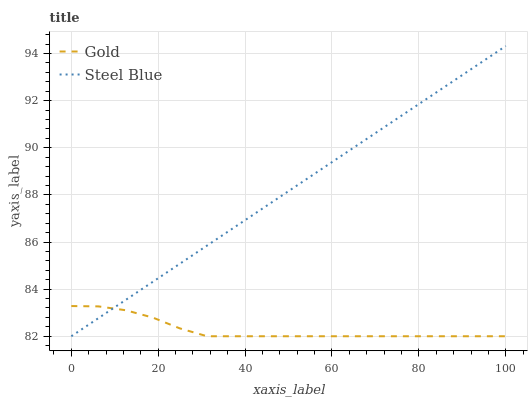Does Gold have the maximum area under the curve?
Answer yes or no. No. Is Gold the smoothest?
Answer yes or no. No. Does Gold have the highest value?
Answer yes or no. No. 